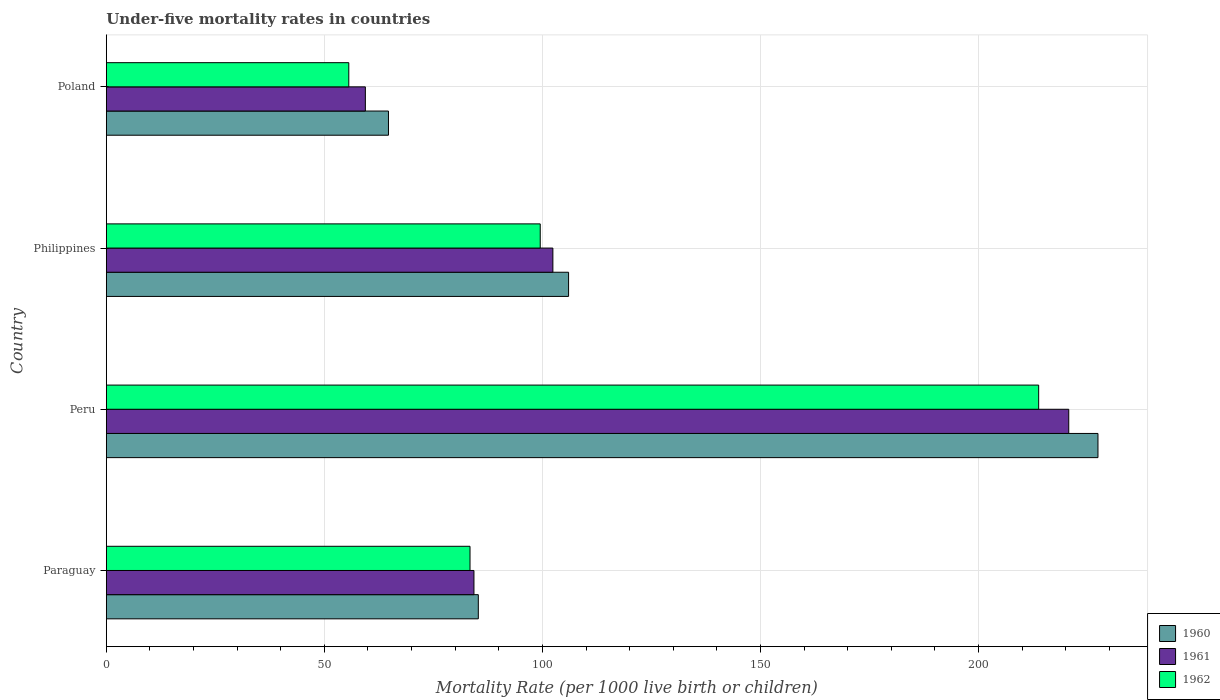Are the number of bars per tick equal to the number of legend labels?
Your answer should be very brief. Yes. How many bars are there on the 1st tick from the top?
Offer a terse response. 3. What is the under-five mortality rate in 1962 in Poland?
Provide a succinct answer. 55.6. Across all countries, what is the maximum under-five mortality rate in 1962?
Offer a terse response. 213.8. Across all countries, what is the minimum under-five mortality rate in 1961?
Your answer should be compact. 59.4. In which country was the under-five mortality rate in 1960 maximum?
Make the answer very short. Peru. What is the total under-five mortality rate in 1961 in the graph?
Provide a short and direct response. 466.8. What is the difference between the under-five mortality rate in 1961 in Peru and that in Philippines?
Keep it short and to the point. 118.3. What is the difference between the under-five mortality rate in 1961 in Peru and the under-five mortality rate in 1962 in Philippines?
Make the answer very short. 121.2. What is the average under-five mortality rate in 1962 per country?
Your response must be concise. 113.08. What is the difference between the under-five mortality rate in 1960 and under-five mortality rate in 1962 in Peru?
Give a very brief answer. 13.6. What is the ratio of the under-five mortality rate in 1961 in Paraguay to that in Peru?
Offer a very short reply. 0.38. Is the under-five mortality rate in 1962 in Peru less than that in Poland?
Your response must be concise. No. Is the difference between the under-five mortality rate in 1960 in Peru and Poland greater than the difference between the under-five mortality rate in 1962 in Peru and Poland?
Provide a short and direct response. Yes. What is the difference between the highest and the second highest under-five mortality rate in 1962?
Offer a terse response. 114.3. What is the difference between the highest and the lowest under-five mortality rate in 1962?
Provide a short and direct response. 158.2. In how many countries, is the under-five mortality rate in 1962 greater than the average under-five mortality rate in 1962 taken over all countries?
Ensure brevity in your answer.  1. Is the sum of the under-five mortality rate in 1961 in Paraguay and Peru greater than the maximum under-five mortality rate in 1962 across all countries?
Make the answer very short. Yes. Is it the case that in every country, the sum of the under-five mortality rate in 1962 and under-five mortality rate in 1961 is greater than the under-five mortality rate in 1960?
Ensure brevity in your answer.  Yes. How many bars are there?
Ensure brevity in your answer.  12. Are all the bars in the graph horizontal?
Your answer should be very brief. Yes. How many countries are there in the graph?
Ensure brevity in your answer.  4. What is the difference between two consecutive major ticks on the X-axis?
Keep it short and to the point. 50. Where does the legend appear in the graph?
Your response must be concise. Bottom right. How many legend labels are there?
Offer a terse response. 3. What is the title of the graph?
Your response must be concise. Under-five mortality rates in countries. What is the label or title of the X-axis?
Your response must be concise. Mortality Rate (per 1000 live birth or children). What is the Mortality Rate (per 1000 live birth or children) in 1960 in Paraguay?
Give a very brief answer. 85.3. What is the Mortality Rate (per 1000 live birth or children) of 1961 in Paraguay?
Provide a short and direct response. 84.3. What is the Mortality Rate (per 1000 live birth or children) in 1962 in Paraguay?
Provide a short and direct response. 83.4. What is the Mortality Rate (per 1000 live birth or children) in 1960 in Peru?
Keep it short and to the point. 227.4. What is the Mortality Rate (per 1000 live birth or children) in 1961 in Peru?
Provide a succinct answer. 220.7. What is the Mortality Rate (per 1000 live birth or children) in 1962 in Peru?
Give a very brief answer. 213.8. What is the Mortality Rate (per 1000 live birth or children) in 1960 in Philippines?
Your answer should be very brief. 106. What is the Mortality Rate (per 1000 live birth or children) in 1961 in Philippines?
Give a very brief answer. 102.4. What is the Mortality Rate (per 1000 live birth or children) in 1962 in Philippines?
Keep it short and to the point. 99.5. What is the Mortality Rate (per 1000 live birth or children) in 1960 in Poland?
Your response must be concise. 64.7. What is the Mortality Rate (per 1000 live birth or children) in 1961 in Poland?
Provide a short and direct response. 59.4. What is the Mortality Rate (per 1000 live birth or children) of 1962 in Poland?
Give a very brief answer. 55.6. Across all countries, what is the maximum Mortality Rate (per 1000 live birth or children) of 1960?
Ensure brevity in your answer.  227.4. Across all countries, what is the maximum Mortality Rate (per 1000 live birth or children) in 1961?
Give a very brief answer. 220.7. Across all countries, what is the maximum Mortality Rate (per 1000 live birth or children) in 1962?
Offer a terse response. 213.8. Across all countries, what is the minimum Mortality Rate (per 1000 live birth or children) of 1960?
Ensure brevity in your answer.  64.7. Across all countries, what is the minimum Mortality Rate (per 1000 live birth or children) in 1961?
Your answer should be compact. 59.4. Across all countries, what is the minimum Mortality Rate (per 1000 live birth or children) in 1962?
Offer a very short reply. 55.6. What is the total Mortality Rate (per 1000 live birth or children) of 1960 in the graph?
Provide a succinct answer. 483.4. What is the total Mortality Rate (per 1000 live birth or children) in 1961 in the graph?
Make the answer very short. 466.8. What is the total Mortality Rate (per 1000 live birth or children) in 1962 in the graph?
Provide a short and direct response. 452.3. What is the difference between the Mortality Rate (per 1000 live birth or children) of 1960 in Paraguay and that in Peru?
Give a very brief answer. -142.1. What is the difference between the Mortality Rate (per 1000 live birth or children) of 1961 in Paraguay and that in Peru?
Your answer should be very brief. -136.4. What is the difference between the Mortality Rate (per 1000 live birth or children) of 1962 in Paraguay and that in Peru?
Offer a very short reply. -130.4. What is the difference between the Mortality Rate (per 1000 live birth or children) in 1960 in Paraguay and that in Philippines?
Keep it short and to the point. -20.7. What is the difference between the Mortality Rate (per 1000 live birth or children) of 1961 in Paraguay and that in Philippines?
Your response must be concise. -18.1. What is the difference between the Mortality Rate (per 1000 live birth or children) of 1962 in Paraguay and that in Philippines?
Make the answer very short. -16.1. What is the difference between the Mortality Rate (per 1000 live birth or children) in 1960 in Paraguay and that in Poland?
Give a very brief answer. 20.6. What is the difference between the Mortality Rate (per 1000 live birth or children) in 1961 in Paraguay and that in Poland?
Make the answer very short. 24.9. What is the difference between the Mortality Rate (per 1000 live birth or children) in 1962 in Paraguay and that in Poland?
Provide a succinct answer. 27.8. What is the difference between the Mortality Rate (per 1000 live birth or children) of 1960 in Peru and that in Philippines?
Provide a short and direct response. 121.4. What is the difference between the Mortality Rate (per 1000 live birth or children) of 1961 in Peru and that in Philippines?
Ensure brevity in your answer.  118.3. What is the difference between the Mortality Rate (per 1000 live birth or children) in 1962 in Peru and that in Philippines?
Your answer should be compact. 114.3. What is the difference between the Mortality Rate (per 1000 live birth or children) in 1960 in Peru and that in Poland?
Keep it short and to the point. 162.7. What is the difference between the Mortality Rate (per 1000 live birth or children) in 1961 in Peru and that in Poland?
Your response must be concise. 161.3. What is the difference between the Mortality Rate (per 1000 live birth or children) of 1962 in Peru and that in Poland?
Offer a very short reply. 158.2. What is the difference between the Mortality Rate (per 1000 live birth or children) of 1960 in Philippines and that in Poland?
Your answer should be very brief. 41.3. What is the difference between the Mortality Rate (per 1000 live birth or children) in 1962 in Philippines and that in Poland?
Provide a short and direct response. 43.9. What is the difference between the Mortality Rate (per 1000 live birth or children) of 1960 in Paraguay and the Mortality Rate (per 1000 live birth or children) of 1961 in Peru?
Your answer should be very brief. -135.4. What is the difference between the Mortality Rate (per 1000 live birth or children) in 1960 in Paraguay and the Mortality Rate (per 1000 live birth or children) in 1962 in Peru?
Give a very brief answer. -128.5. What is the difference between the Mortality Rate (per 1000 live birth or children) of 1961 in Paraguay and the Mortality Rate (per 1000 live birth or children) of 1962 in Peru?
Ensure brevity in your answer.  -129.5. What is the difference between the Mortality Rate (per 1000 live birth or children) of 1960 in Paraguay and the Mortality Rate (per 1000 live birth or children) of 1961 in Philippines?
Give a very brief answer. -17.1. What is the difference between the Mortality Rate (per 1000 live birth or children) of 1960 in Paraguay and the Mortality Rate (per 1000 live birth or children) of 1962 in Philippines?
Keep it short and to the point. -14.2. What is the difference between the Mortality Rate (per 1000 live birth or children) of 1961 in Paraguay and the Mortality Rate (per 1000 live birth or children) of 1962 in Philippines?
Your response must be concise. -15.2. What is the difference between the Mortality Rate (per 1000 live birth or children) of 1960 in Paraguay and the Mortality Rate (per 1000 live birth or children) of 1961 in Poland?
Make the answer very short. 25.9. What is the difference between the Mortality Rate (per 1000 live birth or children) of 1960 in Paraguay and the Mortality Rate (per 1000 live birth or children) of 1962 in Poland?
Your answer should be very brief. 29.7. What is the difference between the Mortality Rate (per 1000 live birth or children) in 1961 in Paraguay and the Mortality Rate (per 1000 live birth or children) in 1962 in Poland?
Ensure brevity in your answer.  28.7. What is the difference between the Mortality Rate (per 1000 live birth or children) of 1960 in Peru and the Mortality Rate (per 1000 live birth or children) of 1961 in Philippines?
Provide a short and direct response. 125. What is the difference between the Mortality Rate (per 1000 live birth or children) in 1960 in Peru and the Mortality Rate (per 1000 live birth or children) in 1962 in Philippines?
Provide a short and direct response. 127.9. What is the difference between the Mortality Rate (per 1000 live birth or children) in 1961 in Peru and the Mortality Rate (per 1000 live birth or children) in 1962 in Philippines?
Ensure brevity in your answer.  121.2. What is the difference between the Mortality Rate (per 1000 live birth or children) in 1960 in Peru and the Mortality Rate (per 1000 live birth or children) in 1961 in Poland?
Provide a short and direct response. 168. What is the difference between the Mortality Rate (per 1000 live birth or children) of 1960 in Peru and the Mortality Rate (per 1000 live birth or children) of 1962 in Poland?
Provide a succinct answer. 171.8. What is the difference between the Mortality Rate (per 1000 live birth or children) of 1961 in Peru and the Mortality Rate (per 1000 live birth or children) of 1962 in Poland?
Provide a short and direct response. 165.1. What is the difference between the Mortality Rate (per 1000 live birth or children) of 1960 in Philippines and the Mortality Rate (per 1000 live birth or children) of 1961 in Poland?
Your response must be concise. 46.6. What is the difference between the Mortality Rate (per 1000 live birth or children) of 1960 in Philippines and the Mortality Rate (per 1000 live birth or children) of 1962 in Poland?
Your response must be concise. 50.4. What is the difference between the Mortality Rate (per 1000 live birth or children) in 1961 in Philippines and the Mortality Rate (per 1000 live birth or children) in 1962 in Poland?
Make the answer very short. 46.8. What is the average Mortality Rate (per 1000 live birth or children) of 1960 per country?
Provide a short and direct response. 120.85. What is the average Mortality Rate (per 1000 live birth or children) of 1961 per country?
Offer a terse response. 116.7. What is the average Mortality Rate (per 1000 live birth or children) of 1962 per country?
Your response must be concise. 113.08. What is the difference between the Mortality Rate (per 1000 live birth or children) of 1960 and Mortality Rate (per 1000 live birth or children) of 1961 in Philippines?
Ensure brevity in your answer.  3.6. What is the difference between the Mortality Rate (per 1000 live birth or children) of 1960 and Mortality Rate (per 1000 live birth or children) of 1962 in Poland?
Provide a succinct answer. 9.1. What is the ratio of the Mortality Rate (per 1000 live birth or children) of 1960 in Paraguay to that in Peru?
Offer a terse response. 0.38. What is the ratio of the Mortality Rate (per 1000 live birth or children) of 1961 in Paraguay to that in Peru?
Offer a terse response. 0.38. What is the ratio of the Mortality Rate (per 1000 live birth or children) of 1962 in Paraguay to that in Peru?
Provide a short and direct response. 0.39. What is the ratio of the Mortality Rate (per 1000 live birth or children) of 1960 in Paraguay to that in Philippines?
Offer a terse response. 0.8. What is the ratio of the Mortality Rate (per 1000 live birth or children) in 1961 in Paraguay to that in Philippines?
Offer a very short reply. 0.82. What is the ratio of the Mortality Rate (per 1000 live birth or children) of 1962 in Paraguay to that in Philippines?
Your response must be concise. 0.84. What is the ratio of the Mortality Rate (per 1000 live birth or children) in 1960 in Paraguay to that in Poland?
Make the answer very short. 1.32. What is the ratio of the Mortality Rate (per 1000 live birth or children) of 1961 in Paraguay to that in Poland?
Offer a terse response. 1.42. What is the ratio of the Mortality Rate (per 1000 live birth or children) of 1960 in Peru to that in Philippines?
Provide a short and direct response. 2.15. What is the ratio of the Mortality Rate (per 1000 live birth or children) of 1961 in Peru to that in Philippines?
Give a very brief answer. 2.16. What is the ratio of the Mortality Rate (per 1000 live birth or children) in 1962 in Peru to that in Philippines?
Offer a terse response. 2.15. What is the ratio of the Mortality Rate (per 1000 live birth or children) in 1960 in Peru to that in Poland?
Provide a succinct answer. 3.51. What is the ratio of the Mortality Rate (per 1000 live birth or children) in 1961 in Peru to that in Poland?
Make the answer very short. 3.72. What is the ratio of the Mortality Rate (per 1000 live birth or children) in 1962 in Peru to that in Poland?
Provide a succinct answer. 3.85. What is the ratio of the Mortality Rate (per 1000 live birth or children) of 1960 in Philippines to that in Poland?
Offer a very short reply. 1.64. What is the ratio of the Mortality Rate (per 1000 live birth or children) of 1961 in Philippines to that in Poland?
Offer a very short reply. 1.72. What is the ratio of the Mortality Rate (per 1000 live birth or children) in 1962 in Philippines to that in Poland?
Keep it short and to the point. 1.79. What is the difference between the highest and the second highest Mortality Rate (per 1000 live birth or children) in 1960?
Your answer should be compact. 121.4. What is the difference between the highest and the second highest Mortality Rate (per 1000 live birth or children) in 1961?
Offer a terse response. 118.3. What is the difference between the highest and the second highest Mortality Rate (per 1000 live birth or children) in 1962?
Keep it short and to the point. 114.3. What is the difference between the highest and the lowest Mortality Rate (per 1000 live birth or children) in 1960?
Give a very brief answer. 162.7. What is the difference between the highest and the lowest Mortality Rate (per 1000 live birth or children) of 1961?
Give a very brief answer. 161.3. What is the difference between the highest and the lowest Mortality Rate (per 1000 live birth or children) in 1962?
Make the answer very short. 158.2. 